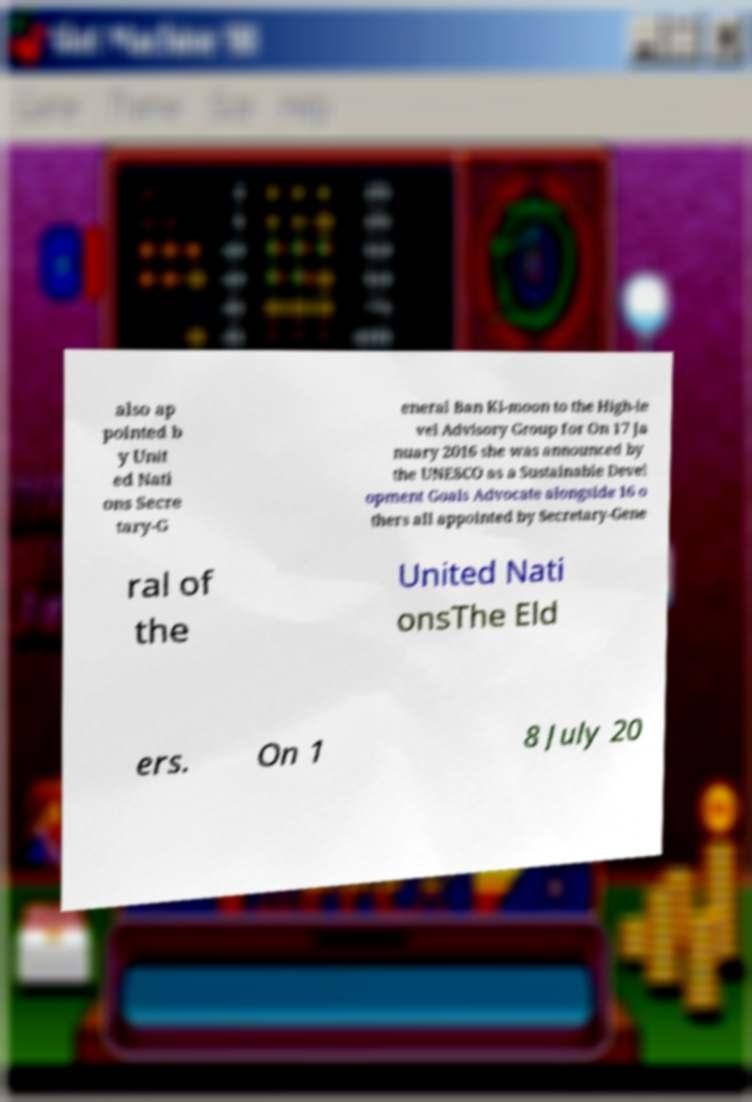Can you read and provide the text displayed in the image?This photo seems to have some interesting text. Can you extract and type it out for me? also ap pointed b y Unit ed Nati ons Secre tary-G eneral Ban Ki-moon to the High-le vel Advisory Group for On 17 Ja nuary 2016 she was announced by the UNESCO as a Sustainable Devel opment Goals Advocate alongside 16 o thers all appointed by Secretary-Gene ral of the United Nati onsThe Eld ers. On 1 8 July 20 